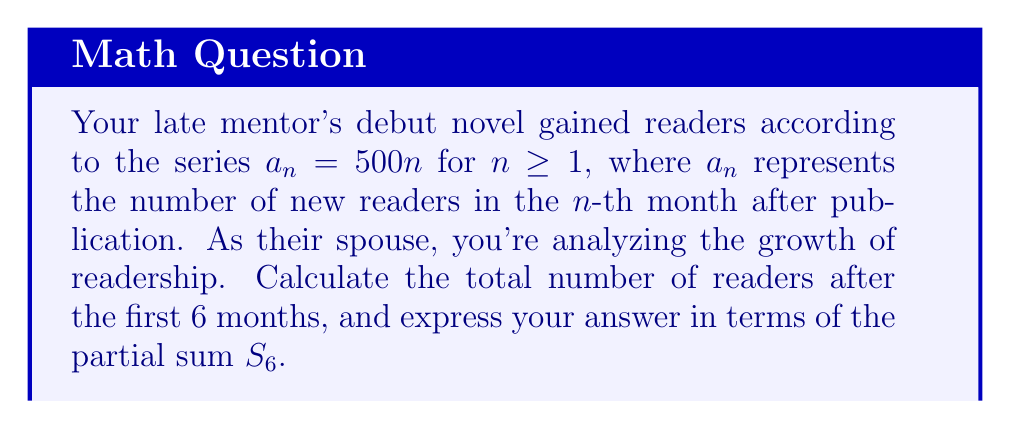Can you solve this math problem? Let's approach this step-by-step:

1) The series given is $a_n = 500n$ for $n \geq 1$. This is an arithmetic sequence with a common difference of 500.

2) We need to find the partial sum $S_6$, which represents the total number of readers after 6 months.

3) The partial sum of an arithmetic sequence is given by the formula:

   $$S_n = \frac{n(a_1 + a_n)}{2}$$

   where $a_1$ is the first term and $a_n$ is the $n$-th term.

4) In our case:
   $a_1 = 500 \cdot 1 = 500$
   $a_6 = 500 \cdot 6 = 3000$
   $n = 6$

5) Substituting these values into the formula:

   $$S_6 = \frac{6(500 + 3000)}{2}$$

6) Simplifying:
   $$S_6 = \frac{6(3500)}{2} = \frac{21000}{2} = 10500$$

Therefore, the total number of readers after 6 months is 10,500.
Answer: $S_6 = 10500$ readers 